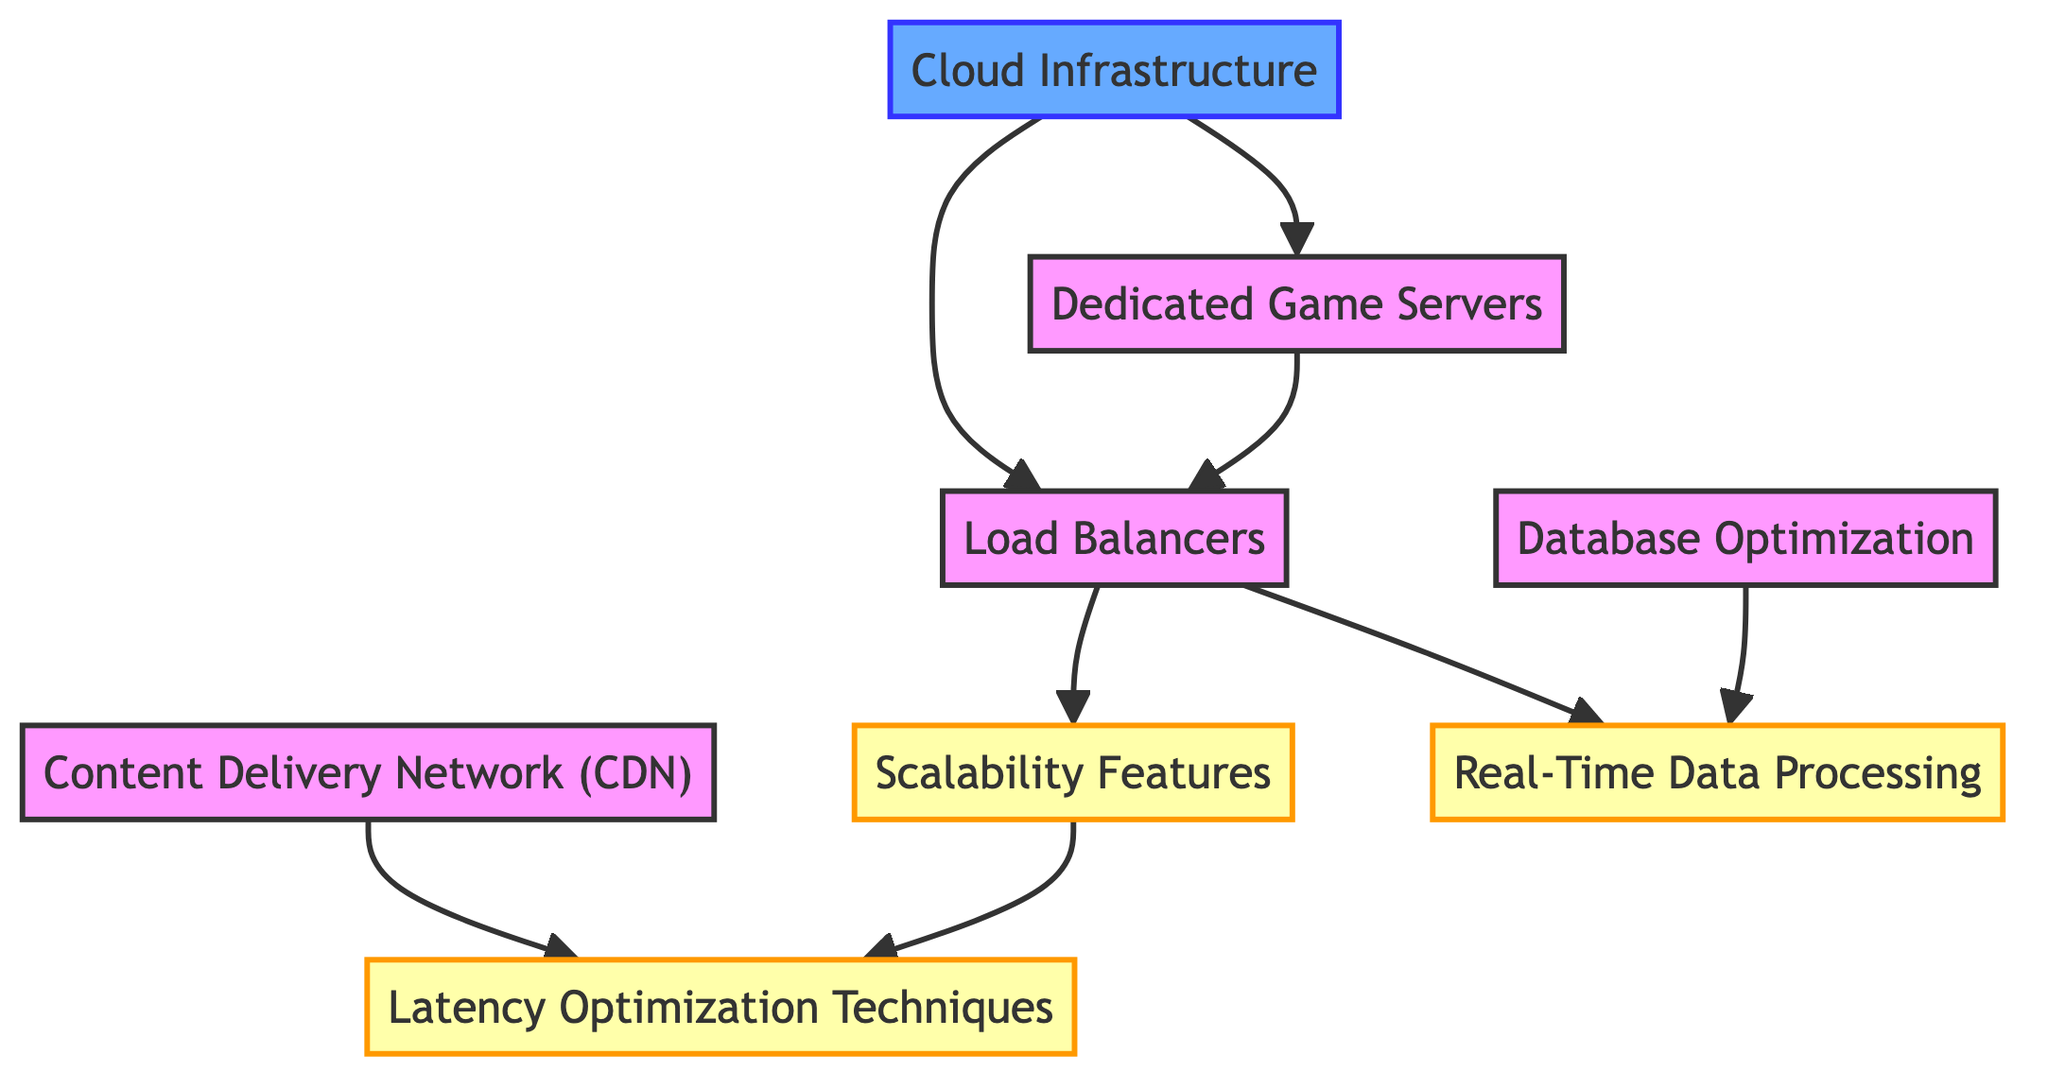What's the total number of nodes in the diagram? The diagram contains eight distinct nodes: Dedicated Game Servers, Load Balancers, Database Optimization, Content Delivery Network (CDN), Real-Time Data Processing, Cloud Infrastructure, Scalability Features, and Latency Optimization Techniques. Counting these nodes gives a total of eight.
Answer: 8 Which node connects directly to Load Balancers? From the diagram, the nodes that connect directly to Load Balancers are Dedicated Game Servers and Real-Time Data Processing, as well as Scalability Features. However, since the question asks for just one, we can mention the first one found in the diagram, which is Dedicated Game Servers.
Answer: Dedicated Game Servers What type of infrastructure is connected to Dedicated Game Servers? The connected node to Dedicated Game Servers is Cloud Infrastructure, which indicates the type of infrastructure supporting the servers. There is a direct edge leading from Cloud Infrastructure to Dedicated Game Servers.
Answer: Cloud Infrastructure How many edges connect to Scalability? Scalability has two incoming edges; one from Load Balancers and another from the Scalability node itself to Latency Optimization Techniques. This means Scalability is an influential feature that impacts multiple aspects of the server architecture. Counting only the edges leading into Scalability confirms that there are two.
Answer: 2 Which node can optimize database performance? Database Optimization is the dedicated node that focuses on optimizing the database in the directed graph. It connects directly to the Real-Time Data Processing node, indicating its role in improving the database's performance and interaction with processing data in real-time.
Answer: Database Optimization If the system experiences high traffic, which node handles it? The Load Balancers node directly supports managing high traffic by distributing incoming connections to Dedicated Game Servers for optimal performance. The connections also highlight how the Load Balancers manage server loads effectively in multiplayer scenarios.
Answer: Load Balancers What is the relationship between Content Delivery Network and Latency Optimization? The Content Delivery Network connects directly to Latency Optimization Techniques in the diagram. This relationship demonstrates that the use of a CDN can reduce latency, improving the overall user experience in multiplayer gaming.
Answer: Direct connection Name a feature that both Database Optimization and Load Balancers contribute to. Both Database Optimization and Load Balancers contribute indirectly to Real-Time Data Processing. Database Optimization aids its efficiency, while Load Balancers manage the load and traffic to ensure that the data processing remains smooth in real-time scenarios.
Answer: Real-Time Data Processing 